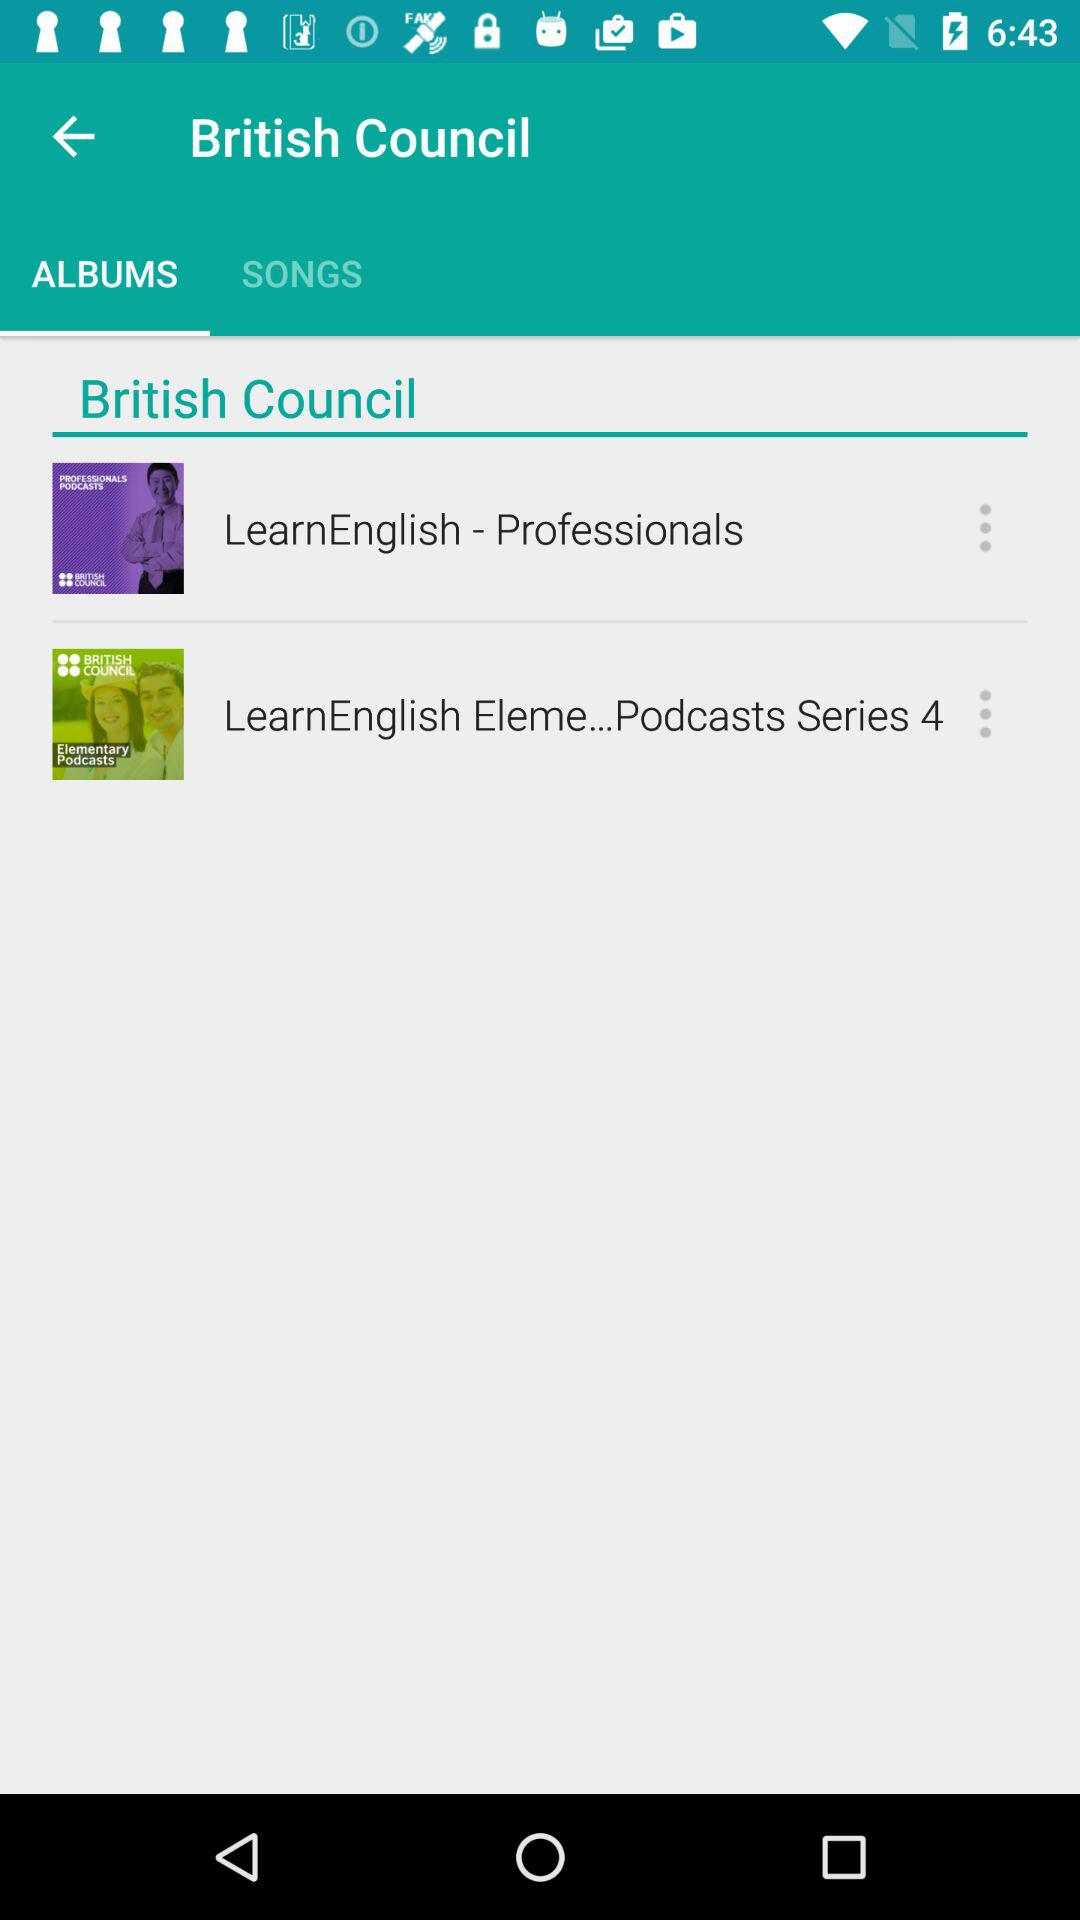Which tab is selected? The selected tab is "ALBUMS". 